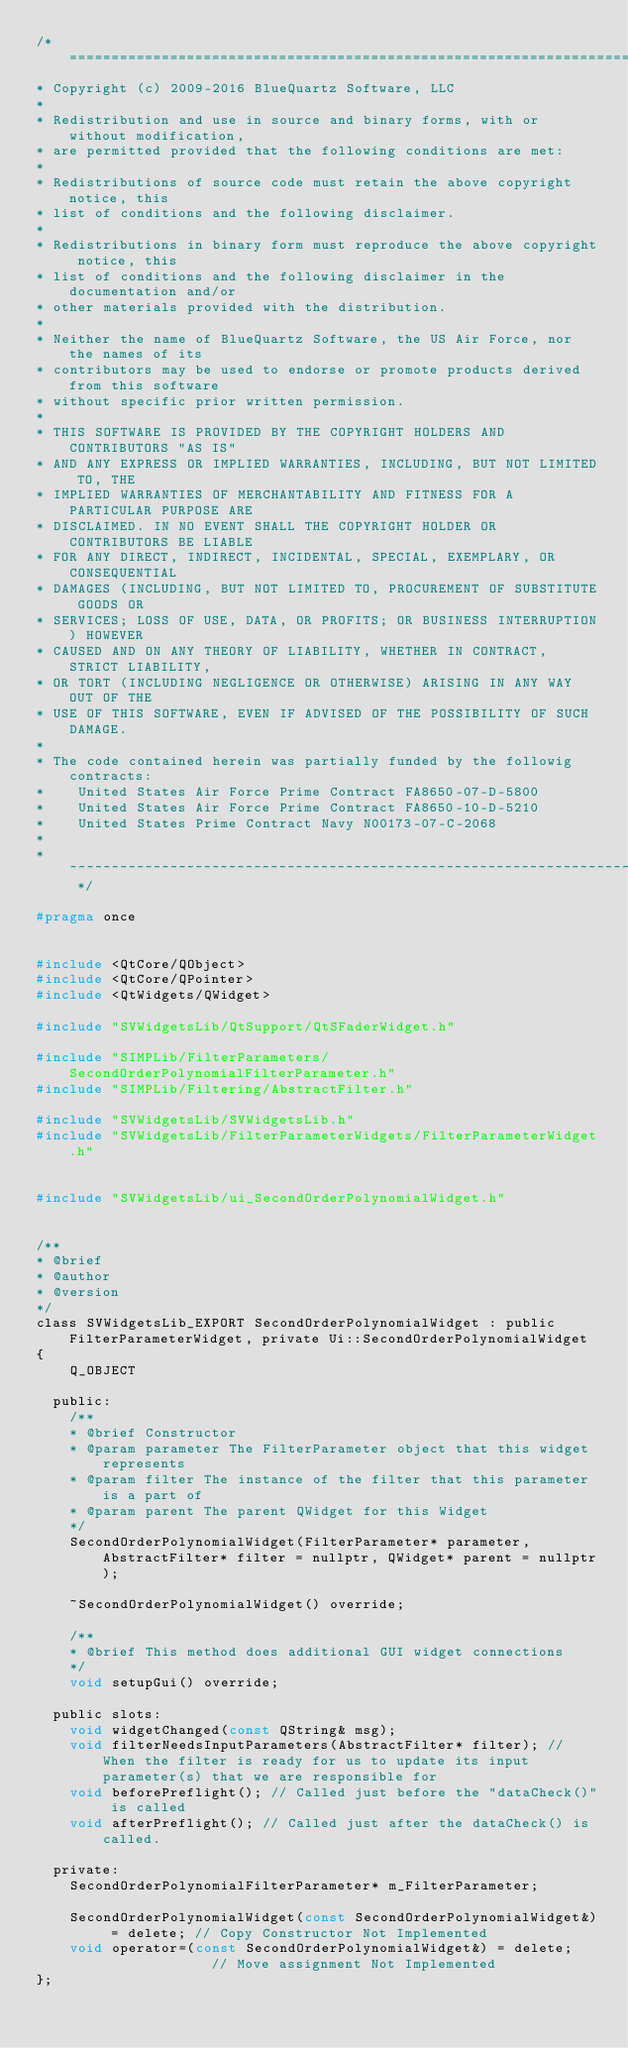<code> <loc_0><loc_0><loc_500><loc_500><_C_>/* ============================================================================
* Copyright (c) 2009-2016 BlueQuartz Software, LLC
*
* Redistribution and use in source and binary forms, with or without modification,
* are permitted provided that the following conditions are met:
*
* Redistributions of source code must retain the above copyright notice, this
* list of conditions and the following disclaimer.
*
* Redistributions in binary form must reproduce the above copyright notice, this
* list of conditions and the following disclaimer in the documentation and/or
* other materials provided with the distribution.
*
* Neither the name of BlueQuartz Software, the US Air Force, nor the names of its
* contributors may be used to endorse or promote products derived from this software
* without specific prior written permission.
*
* THIS SOFTWARE IS PROVIDED BY THE COPYRIGHT HOLDERS AND CONTRIBUTORS "AS IS"
* AND ANY EXPRESS OR IMPLIED WARRANTIES, INCLUDING, BUT NOT LIMITED TO, THE
* IMPLIED WARRANTIES OF MERCHANTABILITY AND FITNESS FOR A PARTICULAR PURPOSE ARE
* DISCLAIMED. IN NO EVENT SHALL THE COPYRIGHT HOLDER OR CONTRIBUTORS BE LIABLE
* FOR ANY DIRECT, INDIRECT, INCIDENTAL, SPECIAL, EXEMPLARY, OR CONSEQUENTIAL
* DAMAGES (INCLUDING, BUT NOT LIMITED TO, PROCUREMENT OF SUBSTITUTE GOODS OR
* SERVICES; LOSS OF USE, DATA, OR PROFITS; OR BUSINESS INTERRUPTION) HOWEVER
* CAUSED AND ON ANY THEORY OF LIABILITY, WHETHER IN CONTRACT, STRICT LIABILITY,
* OR TORT (INCLUDING NEGLIGENCE OR OTHERWISE) ARISING IN ANY WAY OUT OF THE
* USE OF THIS SOFTWARE, EVEN IF ADVISED OF THE POSSIBILITY OF SUCH DAMAGE.
*
* The code contained herein was partially funded by the followig contracts:
*    United States Air Force Prime Contract FA8650-07-D-5800
*    United States Air Force Prime Contract FA8650-10-D-5210
*    United States Prime Contract Navy N00173-07-C-2068
*
* ~~~~~~~~~~~~~~~~~~~~~~~~~~~~~~~~~~~~~~~~~~~~~~~~~~~~~~~~~~~~~~~~~~~~~~~~~~ */

#pragma once


#include <QtCore/QObject>
#include <QtCore/QPointer>
#include <QtWidgets/QWidget>

#include "SVWidgetsLib/QtSupport/QtSFaderWidget.h"

#include "SIMPLib/FilterParameters/SecondOrderPolynomialFilterParameter.h"
#include "SIMPLib/Filtering/AbstractFilter.h"

#include "SVWidgetsLib/SVWidgetsLib.h"
#include "SVWidgetsLib/FilterParameterWidgets/FilterParameterWidget.h"


#include "SVWidgetsLib/ui_SecondOrderPolynomialWidget.h"


/**
* @brief
* @author
* @version
*/
class SVWidgetsLib_EXPORT SecondOrderPolynomialWidget : public FilterParameterWidget, private Ui::SecondOrderPolynomialWidget
{
    Q_OBJECT

  public:
    /**
    * @brief Constructor
    * @param parameter The FilterParameter object that this widget represents
    * @param filter The instance of the filter that this parameter is a part of
    * @param parent The parent QWidget for this Widget
    */
    SecondOrderPolynomialWidget(FilterParameter* parameter, AbstractFilter* filter = nullptr, QWidget* parent = nullptr);

    ~SecondOrderPolynomialWidget() override;

    /**
    * @brief This method does additional GUI widget connections
    */
    void setupGui() override;

  public slots:
    void widgetChanged(const QString& msg);
    void filterNeedsInputParameters(AbstractFilter* filter); // When the filter is ready for us to update its input parameter(s) that we are responsible for
    void beforePreflight(); // Called just before the "dataCheck()" is called
    void afterPreflight(); // Called just after the dataCheck() is called.

  private:
    SecondOrderPolynomialFilterParameter* m_FilterParameter;

    SecondOrderPolynomialWidget(const SecondOrderPolynomialWidget&) = delete; // Copy Constructor Not Implemented
    void operator=(const SecondOrderPolynomialWidget&) = delete;              // Move assignment Not Implemented
};



</code> 